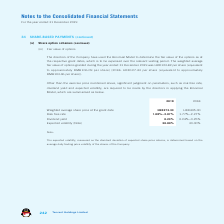According to Tencent's financial document, How did the directors  determine the fair value of the options as at the respective grant dates? According to the financial document, Binomial Model. The relevant text states: "The directors of the Company have used the Binomial Model to determine the fair value of the options as at..." Also, How much was the weighted average fair value per share of options granted during the year ended 31 December 2019 in RMB? Based on the financial document, the answer is HKD123.82 per share (equivalent to approximately RMB106.09 per share). Also, How much was the weighted average fair value per share of options granted during the year ended 31 December 2018 in RMB? HKD127.43 per share (equivalent to approximately RMB103.46 per share). The document states: "to approximately RMB106.09 per share) (2018: HKD127.43 per share (equivalent to approximately RMB103.46 per share))...." Also, can you calculate: How much did the Weighted average share price at the grant date change by between 2018 and 2019? Based on the calculation: 373.33-405.00, the result is -31.67. This is based on the information: "verage share price at the grant date HKD373.33 HKD405.00 Weighted average share price at the grant date HKD373.33 HKD405.00..." The key data points involved are: 373.33, 405.00. Also, can you calculate: How much did the Expected volatility change by between 2018 and 2019? I cannot find a specific answer to this question in the financial document. Also, can you calculate: How much did the weighted average fair value per share of options granted change by in RMB between 2018 and 2019 year end? Based on the calculation:  106.09-103.46, the result is 2.63. This is based on the information: "to approximately RMB106.09 per share) (2018: HKD127.43 per share (equivalent to approximately RMB103.46 per share))...." The key data points involved are: 103.46, 106.09. 